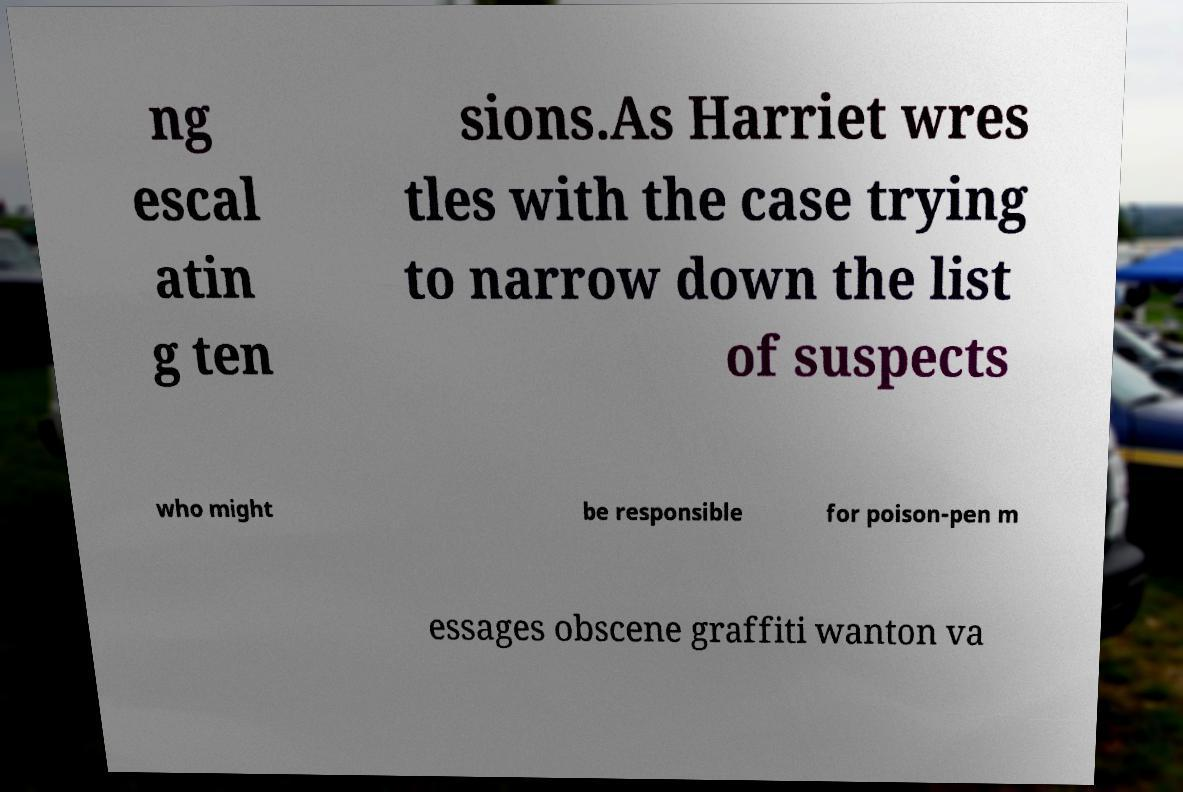Please identify and transcribe the text found in this image. ng escal atin g ten sions.As Harriet wres tles with the case trying to narrow down the list of suspects who might be responsible for poison-pen m essages obscene graffiti wanton va 